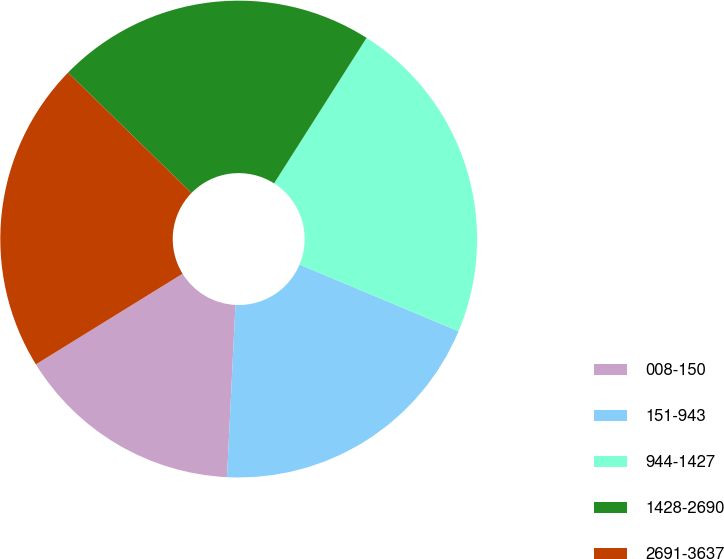Convert chart to OTSL. <chart><loc_0><loc_0><loc_500><loc_500><pie_chart><fcel>008-150<fcel>151-943<fcel>944-1427<fcel>1428-2690<fcel>2691-3637<nl><fcel>15.41%<fcel>19.46%<fcel>22.31%<fcel>21.71%<fcel>21.11%<nl></chart> 